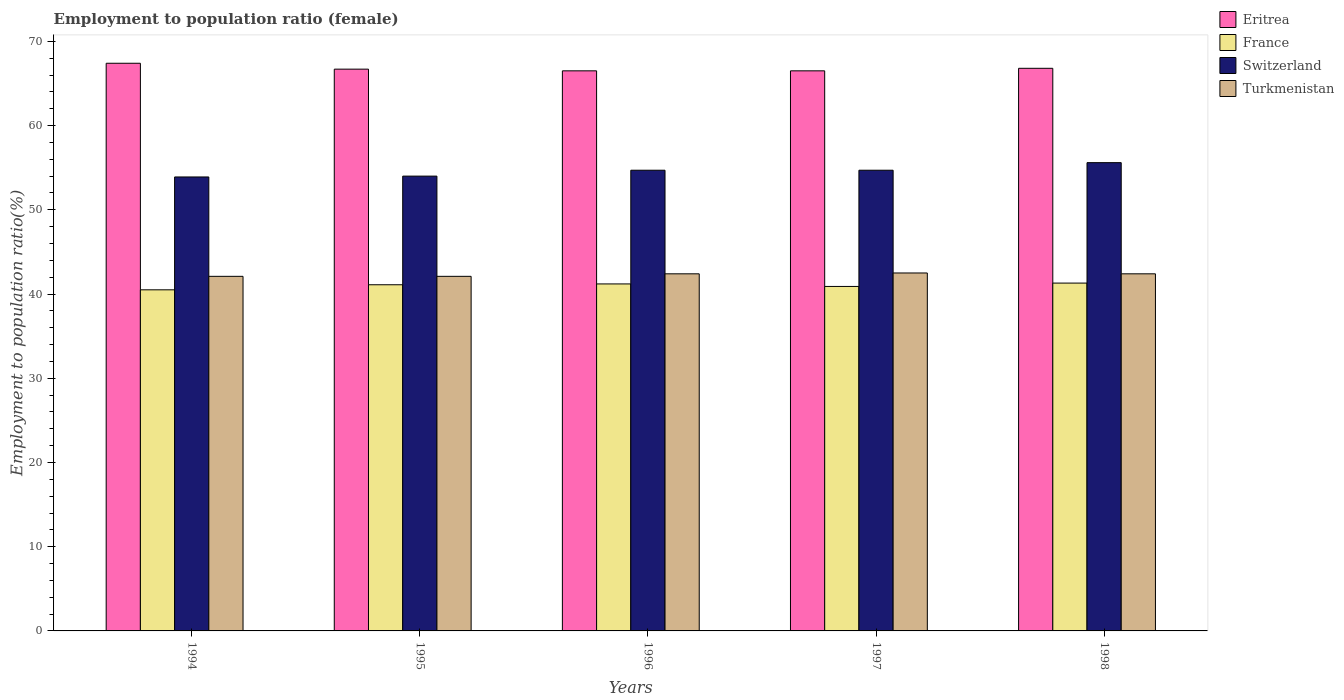How many groups of bars are there?
Your response must be concise. 5. Are the number of bars per tick equal to the number of legend labels?
Provide a short and direct response. Yes. How many bars are there on the 4th tick from the left?
Offer a terse response. 4. How many bars are there on the 1st tick from the right?
Give a very brief answer. 4. What is the label of the 2nd group of bars from the left?
Your response must be concise. 1995. What is the employment to population ratio in Switzerland in 1995?
Provide a succinct answer. 54. Across all years, what is the maximum employment to population ratio in Switzerland?
Your answer should be compact. 55.6. Across all years, what is the minimum employment to population ratio in Eritrea?
Give a very brief answer. 66.5. What is the total employment to population ratio in Switzerland in the graph?
Offer a very short reply. 272.9. What is the difference between the employment to population ratio in Turkmenistan in 1998 and the employment to population ratio in Eritrea in 1997?
Provide a succinct answer. -24.1. What is the average employment to population ratio in Turkmenistan per year?
Your answer should be very brief. 42.3. In the year 1994, what is the difference between the employment to population ratio in France and employment to population ratio in Switzerland?
Keep it short and to the point. -13.4. What is the ratio of the employment to population ratio in Eritrea in 1994 to that in 1995?
Offer a terse response. 1.01. Is the employment to population ratio in Turkmenistan in 1996 less than that in 1998?
Offer a terse response. No. Is the difference between the employment to population ratio in France in 1994 and 1996 greater than the difference between the employment to population ratio in Switzerland in 1994 and 1996?
Keep it short and to the point. Yes. What is the difference between the highest and the second highest employment to population ratio in Switzerland?
Your response must be concise. 0.9. What is the difference between the highest and the lowest employment to population ratio in Eritrea?
Make the answer very short. 0.9. In how many years, is the employment to population ratio in Turkmenistan greater than the average employment to population ratio in Turkmenistan taken over all years?
Your answer should be very brief. 3. Is it the case that in every year, the sum of the employment to population ratio in Eritrea and employment to population ratio in Switzerland is greater than the sum of employment to population ratio in France and employment to population ratio in Turkmenistan?
Your answer should be very brief. Yes. What does the 2nd bar from the left in 1997 represents?
Your response must be concise. France. Is it the case that in every year, the sum of the employment to population ratio in France and employment to population ratio in Turkmenistan is greater than the employment to population ratio in Eritrea?
Make the answer very short. Yes. How many years are there in the graph?
Ensure brevity in your answer.  5. What is the difference between two consecutive major ticks on the Y-axis?
Offer a very short reply. 10. Are the values on the major ticks of Y-axis written in scientific E-notation?
Give a very brief answer. No. Does the graph contain grids?
Make the answer very short. No. How are the legend labels stacked?
Ensure brevity in your answer.  Vertical. What is the title of the graph?
Your answer should be compact. Employment to population ratio (female). What is the label or title of the X-axis?
Give a very brief answer. Years. What is the Employment to population ratio(%) in Eritrea in 1994?
Your answer should be very brief. 67.4. What is the Employment to population ratio(%) in France in 1994?
Offer a terse response. 40.5. What is the Employment to population ratio(%) of Switzerland in 1994?
Your answer should be compact. 53.9. What is the Employment to population ratio(%) of Turkmenistan in 1994?
Ensure brevity in your answer.  42.1. What is the Employment to population ratio(%) in Eritrea in 1995?
Your answer should be very brief. 66.7. What is the Employment to population ratio(%) in France in 1995?
Your answer should be very brief. 41.1. What is the Employment to population ratio(%) of Switzerland in 1995?
Make the answer very short. 54. What is the Employment to population ratio(%) of Turkmenistan in 1995?
Make the answer very short. 42.1. What is the Employment to population ratio(%) in Eritrea in 1996?
Provide a short and direct response. 66.5. What is the Employment to population ratio(%) in France in 1996?
Make the answer very short. 41.2. What is the Employment to population ratio(%) in Switzerland in 1996?
Ensure brevity in your answer.  54.7. What is the Employment to population ratio(%) in Turkmenistan in 1996?
Your response must be concise. 42.4. What is the Employment to population ratio(%) of Eritrea in 1997?
Provide a succinct answer. 66.5. What is the Employment to population ratio(%) of France in 1997?
Give a very brief answer. 40.9. What is the Employment to population ratio(%) in Switzerland in 1997?
Ensure brevity in your answer.  54.7. What is the Employment to population ratio(%) of Turkmenistan in 1997?
Offer a very short reply. 42.5. What is the Employment to population ratio(%) of Eritrea in 1998?
Ensure brevity in your answer.  66.8. What is the Employment to population ratio(%) in France in 1998?
Make the answer very short. 41.3. What is the Employment to population ratio(%) of Switzerland in 1998?
Your response must be concise. 55.6. What is the Employment to population ratio(%) of Turkmenistan in 1998?
Your response must be concise. 42.4. Across all years, what is the maximum Employment to population ratio(%) of Eritrea?
Offer a terse response. 67.4. Across all years, what is the maximum Employment to population ratio(%) in France?
Offer a terse response. 41.3. Across all years, what is the maximum Employment to population ratio(%) in Switzerland?
Offer a terse response. 55.6. Across all years, what is the maximum Employment to population ratio(%) of Turkmenistan?
Provide a succinct answer. 42.5. Across all years, what is the minimum Employment to population ratio(%) of Eritrea?
Provide a short and direct response. 66.5. Across all years, what is the minimum Employment to population ratio(%) of France?
Your response must be concise. 40.5. Across all years, what is the minimum Employment to population ratio(%) in Switzerland?
Give a very brief answer. 53.9. Across all years, what is the minimum Employment to population ratio(%) in Turkmenistan?
Keep it short and to the point. 42.1. What is the total Employment to population ratio(%) in Eritrea in the graph?
Provide a succinct answer. 333.9. What is the total Employment to population ratio(%) in France in the graph?
Your answer should be compact. 205. What is the total Employment to population ratio(%) of Switzerland in the graph?
Provide a succinct answer. 272.9. What is the total Employment to population ratio(%) in Turkmenistan in the graph?
Your response must be concise. 211.5. What is the difference between the Employment to population ratio(%) in Switzerland in 1994 and that in 1995?
Your response must be concise. -0.1. What is the difference between the Employment to population ratio(%) in Eritrea in 1994 and that in 1996?
Your answer should be compact. 0.9. What is the difference between the Employment to population ratio(%) in Switzerland in 1994 and that in 1996?
Provide a short and direct response. -0.8. What is the difference between the Employment to population ratio(%) in Turkmenistan in 1994 and that in 1996?
Offer a very short reply. -0.3. What is the difference between the Employment to population ratio(%) of Switzerland in 1994 and that in 1997?
Your response must be concise. -0.8. What is the difference between the Employment to population ratio(%) of Turkmenistan in 1994 and that in 1997?
Your response must be concise. -0.4. What is the difference between the Employment to population ratio(%) of Turkmenistan in 1994 and that in 1998?
Your response must be concise. -0.3. What is the difference between the Employment to population ratio(%) of Eritrea in 1995 and that in 1996?
Offer a very short reply. 0.2. What is the difference between the Employment to population ratio(%) in Turkmenistan in 1995 and that in 1996?
Provide a succinct answer. -0.3. What is the difference between the Employment to population ratio(%) of Turkmenistan in 1995 and that in 1997?
Your answer should be very brief. -0.4. What is the difference between the Employment to population ratio(%) in Switzerland in 1995 and that in 1998?
Your answer should be compact. -1.6. What is the difference between the Employment to population ratio(%) of Eritrea in 1996 and that in 1997?
Offer a very short reply. 0. What is the difference between the Employment to population ratio(%) of France in 1996 and that in 1997?
Offer a very short reply. 0.3. What is the difference between the Employment to population ratio(%) of Switzerland in 1996 and that in 1997?
Your answer should be compact. 0. What is the difference between the Employment to population ratio(%) in Turkmenistan in 1996 and that in 1998?
Make the answer very short. 0. What is the difference between the Employment to population ratio(%) of Turkmenistan in 1997 and that in 1998?
Offer a very short reply. 0.1. What is the difference between the Employment to population ratio(%) in Eritrea in 1994 and the Employment to population ratio(%) in France in 1995?
Your response must be concise. 26.3. What is the difference between the Employment to population ratio(%) in Eritrea in 1994 and the Employment to population ratio(%) in Switzerland in 1995?
Provide a succinct answer. 13.4. What is the difference between the Employment to population ratio(%) of Eritrea in 1994 and the Employment to population ratio(%) of Turkmenistan in 1995?
Provide a short and direct response. 25.3. What is the difference between the Employment to population ratio(%) in France in 1994 and the Employment to population ratio(%) in Switzerland in 1995?
Offer a very short reply. -13.5. What is the difference between the Employment to population ratio(%) in Eritrea in 1994 and the Employment to population ratio(%) in France in 1996?
Your answer should be compact. 26.2. What is the difference between the Employment to population ratio(%) in Eritrea in 1994 and the Employment to population ratio(%) in Switzerland in 1996?
Your answer should be very brief. 12.7. What is the difference between the Employment to population ratio(%) in France in 1994 and the Employment to population ratio(%) in Turkmenistan in 1996?
Your answer should be compact. -1.9. What is the difference between the Employment to population ratio(%) in Eritrea in 1994 and the Employment to population ratio(%) in Switzerland in 1997?
Your answer should be compact. 12.7. What is the difference between the Employment to population ratio(%) of Eritrea in 1994 and the Employment to population ratio(%) of Turkmenistan in 1997?
Your answer should be compact. 24.9. What is the difference between the Employment to population ratio(%) of France in 1994 and the Employment to population ratio(%) of Switzerland in 1997?
Make the answer very short. -14.2. What is the difference between the Employment to population ratio(%) in France in 1994 and the Employment to population ratio(%) in Turkmenistan in 1997?
Offer a terse response. -2. What is the difference between the Employment to population ratio(%) in Eritrea in 1994 and the Employment to population ratio(%) in France in 1998?
Make the answer very short. 26.1. What is the difference between the Employment to population ratio(%) in France in 1994 and the Employment to population ratio(%) in Switzerland in 1998?
Offer a very short reply. -15.1. What is the difference between the Employment to population ratio(%) of Switzerland in 1994 and the Employment to population ratio(%) of Turkmenistan in 1998?
Keep it short and to the point. 11.5. What is the difference between the Employment to population ratio(%) of Eritrea in 1995 and the Employment to population ratio(%) of France in 1996?
Your answer should be compact. 25.5. What is the difference between the Employment to population ratio(%) of Eritrea in 1995 and the Employment to population ratio(%) of Turkmenistan in 1996?
Offer a terse response. 24.3. What is the difference between the Employment to population ratio(%) in Eritrea in 1995 and the Employment to population ratio(%) in France in 1997?
Your answer should be compact. 25.8. What is the difference between the Employment to population ratio(%) of Eritrea in 1995 and the Employment to population ratio(%) of Turkmenistan in 1997?
Give a very brief answer. 24.2. What is the difference between the Employment to population ratio(%) in France in 1995 and the Employment to population ratio(%) in Switzerland in 1997?
Your answer should be compact. -13.6. What is the difference between the Employment to population ratio(%) of Eritrea in 1995 and the Employment to population ratio(%) of France in 1998?
Provide a short and direct response. 25.4. What is the difference between the Employment to population ratio(%) of Eritrea in 1995 and the Employment to population ratio(%) of Turkmenistan in 1998?
Keep it short and to the point. 24.3. What is the difference between the Employment to population ratio(%) in Eritrea in 1996 and the Employment to population ratio(%) in France in 1997?
Offer a very short reply. 25.6. What is the difference between the Employment to population ratio(%) of Eritrea in 1996 and the Employment to population ratio(%) of Switzerland in 1997?
Your answer should be compact. 11.8. What is the difference between the Employment to population ratio(%) of Eritrea in 1996 and the Employment to population ratio(%) of Turkmenistan in 1997?
Offer a very short reply. 24. What is the difference between the Employment to population ratio(%) of France in 1996 and the Employment to population ratio(%) of Switzerland in 1997?
Make the answer very short. -13.5. What is the difference between the Employment to population ratio(%) of Eritrea in 1996 and the Employment to population ratio(%) of France in 1998?
Make the answer very short. 25.2. What is the difference between the Employment to population ratio(%) in Eritrea in 1996 and the Employment to population ratio(%) in Switzerland in 1998?
Provide a succinct answer. 10.9. What is the difference between the Employment to population ratio(%) of Eritrea in 1996 and the Employment to population ratio(%) of Turkmenistan in 1998?
Your response must be concise. 24.1. What is the difference between the Employment to population ratio(%) of France in 1996 and the Employment to population ratio(%) of Switzerland in 1998?
Ensure brevity in your answer.  -14.4. What is the difference between the Employment to population ratio(%) in France in 1996 and the Employment to population ratio(%) in Turkmenistan in 1998?
Ensure brevity in your answer.  -1.2. What is the difference between the Employment to population ratio(%) in Eritrea in 1997 and the Employment to population ratio(%) in France in 1998?
Your answer should be very brief. 25.2. What is the difference between the Employment to population ratio(%) of Eritrea in 1997 and the Employment to population ratio(%) of Switzerland in 1998?
Provide a succinct answer. 10.9. What is the difference between the Employment to population ratio(%) of Eritrea in 1997 and the Employment to population ratio(%) of Turkmenistan in 1998?
Make the answer very short. 24.1. What is the difference between the Employment to population ratio(%) in France in 1997 and the Employment to population ratio(%) in Switzerland in 1998?
Make the answer very short. -14.7. What is the difference between the Employment to population ratio(%) in France in 1997 and the Employment to population ratio(%) in Turkmenistan in 1998?
Your answer should be compact. -1.5. What is the average Employment to population ratio(%) in Eritrea per year?
Ensure brevity in your answer.  66.78. What is the average Employment to population ratio(%) of Switzerland per year?
Provide a succinct answer. 54.58. What is the average Employment to population ratio(%) in Turkmenistan per year?
Your response must be concise. 42.3. In the year 1994, what is the difference between the Employment to population ratio(%) of Eritrea and Employment to population ratio(%) of France?
Your answer should be compact. 26.9. In the year 1994, what is the difference between the Employment to population ratio(%) in Eritrea and Employment to population ratio(%) in Switzerland?
Give a very brief answer. 13.5. In the year 1994, what is the difference between the Employment to population ratio(%) of Eritrea and Employment to population ratio(%) of Turkmenistan?
Offer a terse response. 25.3. In the year 1994, what is the difference between the Employment to population ratio(%) in France and Employment to population ratio(%) in Switzerland?
Give a very brief answer. -13.4. In the year 1994, what is the difference between the Employment to population ratio(%) of France and Employment to population ratio(%) of Turkmenistan?
Give a very brief answer. -1.6. In the year 1994, what is the difference between the Employment to population ratio(%) of Switzerland and Employment to population ratio(%) of Turkmenistan?
Keep it short and to the point. 11.8. In the year 1995, what is the difference between the Employment to population ratio(%) in Eritrea and Employment to population ratio(%) in France?
Provide a succinct answer. 25.6. In the year 1995, what is the difference between the Employment to population ratio(%) of Eritrea and Employment to population ratio(%) of Switzerland?
Offer a very short reply. 12.7. In the year 1995, what is the difference between the Employment to population ratio(%) in Eritrea and Employment to population ratio(%) in Turkmenistan?
Your answer should be compact. 24.6. In the year 1995, what is the difference between the Employment to population ratio(%) of France and Employment to population ratio(%) of Switzerland?
Offer a terse response. -12.9. In the year 1995, what is the difference between the Employment to population ratio(%) of France and Employment to population ratio(%) of Turkmenistan?
Keep it short and to the point. -1. In the year 1996, what is the difference between the Employment to population ratio(%) of Eritrea and Employment to population ratio(%) of France?
Ensure brevity in your answer.  25.3. In the year 1996, what is the difference between the Employment to population ratio(%) in Eritrea and Employment to population ratio(%) in Turkmenistan?
Offer a very short reply. 24.1. In the year 1996, what is the difference between the Employment to population ratio(%) of France and Employment to population ratio(%) of Turkmenistan?
Make the answer very short. -1.2. In the year 1997, what is the difference between the Employment to population ratio(%) in Eritrea and Employment to population ratio(%) in France?
Make the answer very short. 25.6. In the year 1997, what is the difference between the Employment to population ratio(%) in France and Employment to population ratio(%) in Switzerland?
Offer a very short reply. -13.8. In the year 1997, what is the difference between the Employment to population ratio(%) of Switzerland and Employment to population ratio(%) of Turkmenistan?
Provide a succinct answer. 12.2. In the year 1998, what is the difference between the Employment to population ratio(%) of Eritrea and Employment to population ratio(%) of France?
Your answer should be compact. 25.5. In the year 1998, what is the difference between the Employment to population ratio(%) in Eritrea and Employment to population ratio(%) in Turkmenistan?
Make the answer very short. 24.4. In the year 1998, what is the difference between the Employment to population ratio(%) of France and Employment to population ratio(%) of Switzerland?
Provide a short and direct response. -14.3. In the year 1998, what is the difference between the Employment to population ratio(%) of Switzerland and Employment to population ratio(%) of Turkmenistan?
Your answer should be very brief. 13.2. What is the ratio of the Employment to population ratio(%) of Eritrea in 1994 to that in 1995?
Ensure brevity in your answer.  1.01. What is the ratio of the Employment to population ratio(%) of France in 1994 to that in 1995?
Your response must be concise. 0.99. What is the ratio of the Employment to population ratio(%) in Switzerland in 1994 to that in 1995?
Ensure brevity in your answer.  1. What is the ratio of the Employment to population ratio(%) in Turkmenistan in 1994 to that in 1995?
Offer a very short reply. 1. What is the ratio of the Employment to population ratio(%) of Eritrea in 1994 to that in 1996?
Your answer should be very brief. 1.01. What is the ratio of the Employment to population ratio(%) in Switzerland in 1994 to that in 1996?
Ensure brevity in your answer.  0.99. What is the ratio of the Employment to population ratio(%) in Eritrea in 1994 to that in 1997?
Offer a very short reply. 1.01. What is the ratio of the Employment to population ratio(%) of France in 1994 to that in 1997?
Provide a short and direct response. 0.99. What is the ratio of the Employment to population ratio(%) of Switzerland in 1994 to that in 1997?
Offer a terse response. 0.99. What is the ratio of the Employment to population ratio(%) of Turkmenistan in 1994 to that in 1997?
Provide a succinct answer. 0.99. What is the ratio of the Employment to population ratio(%) in France in 1994 to that in 1998?
Make the answer very short. 0.98. What is the ratio of the Employment to population ratio(%) of Switzerland in 1994 to that in 1998?
Your answer should be compact. 0.97. What is the ratio of the Employment to population ratio(%) of Turkmenistan in 1994 to that in 1998?
Make the answer very short. 0.99. What is the ratio of the Employment to population ratio(%) of Eritrea in 1995 to that in 1996?
Ensure brevity in your answer.  1. What is the ratio of the Employment to population ratio(%) of France in 1995 to that in 1996?
Make the answer very short. 1. What is the ratio of the Employment to population ratio(%) in Switzerland in 1995 to that in 1996?
Your answer should be very brief. 0.99. What is the ratio of the Employment to population ratio(%) of Switzerland in 1995 to that in 1997?
Make the answer very short. 0.99. What is the ratio of the Employment to population ratio(%) in Turkmenistan in 1995 to that in 1997?
Your response must be concise. 0.99. What is the ratio of the Employment to population ratio(%) in France in 1995 to that in 1998?
Give a very brief answer. 1. What is the ratio of the Employment to population ratio(%) in Switzerland in 1995 to that in 1998?
Keep it short and to the point. 0.97. What is the ratio of the Employment to population ratio(%) of Turkmenistan in 1995 to that in 1998?
Your answer should be compact. 0.99. What is the ratio of the Employment to population ratio(%) in Eritrea in 1996 to that in 1997?
Keep it short and to the point. 1. What is the ratio of the Employment to population ratio(%) in France in 1996 to that in 1997?
Offer a very short reply. 1.01. What is the ratio of the Employment to population ratio(%) in Turkmenistan in 1996 to that in 1997?
Your answer should be very brief. 1. What is the ratio of the Employment to population ratio(%) in Switzerland in 1996 to that in 1998?
Offer a terse response. 0.98. What is the ratio of the Employment to population ratio(%) of Turkmenistan in 1996 to that in 1998?
Ensure brevity in your answer.  1. What is the ratio of the Employment to population ratio(%) of France in 1997 to that in 1998?
Keep it short and to the point. 0.99. What is the ratio of the Employment to population ratio(%) in Switzerland in 1997 to that in 1998?
Offer a terse response. 0.98. What is the ratio of the Employment to population ratio(%) in Turkmenistan in 1997 to that in 1998?
Provide a succinct answer. 1. What is the difference between the highest and the second highest Employment to population ratio(%) of Eritrea?
Make the answer very short. 0.6. What is the difference between the highest and the lowest Employment to population ratio(%) of France?
Keep it short and to the point. 0.8. 